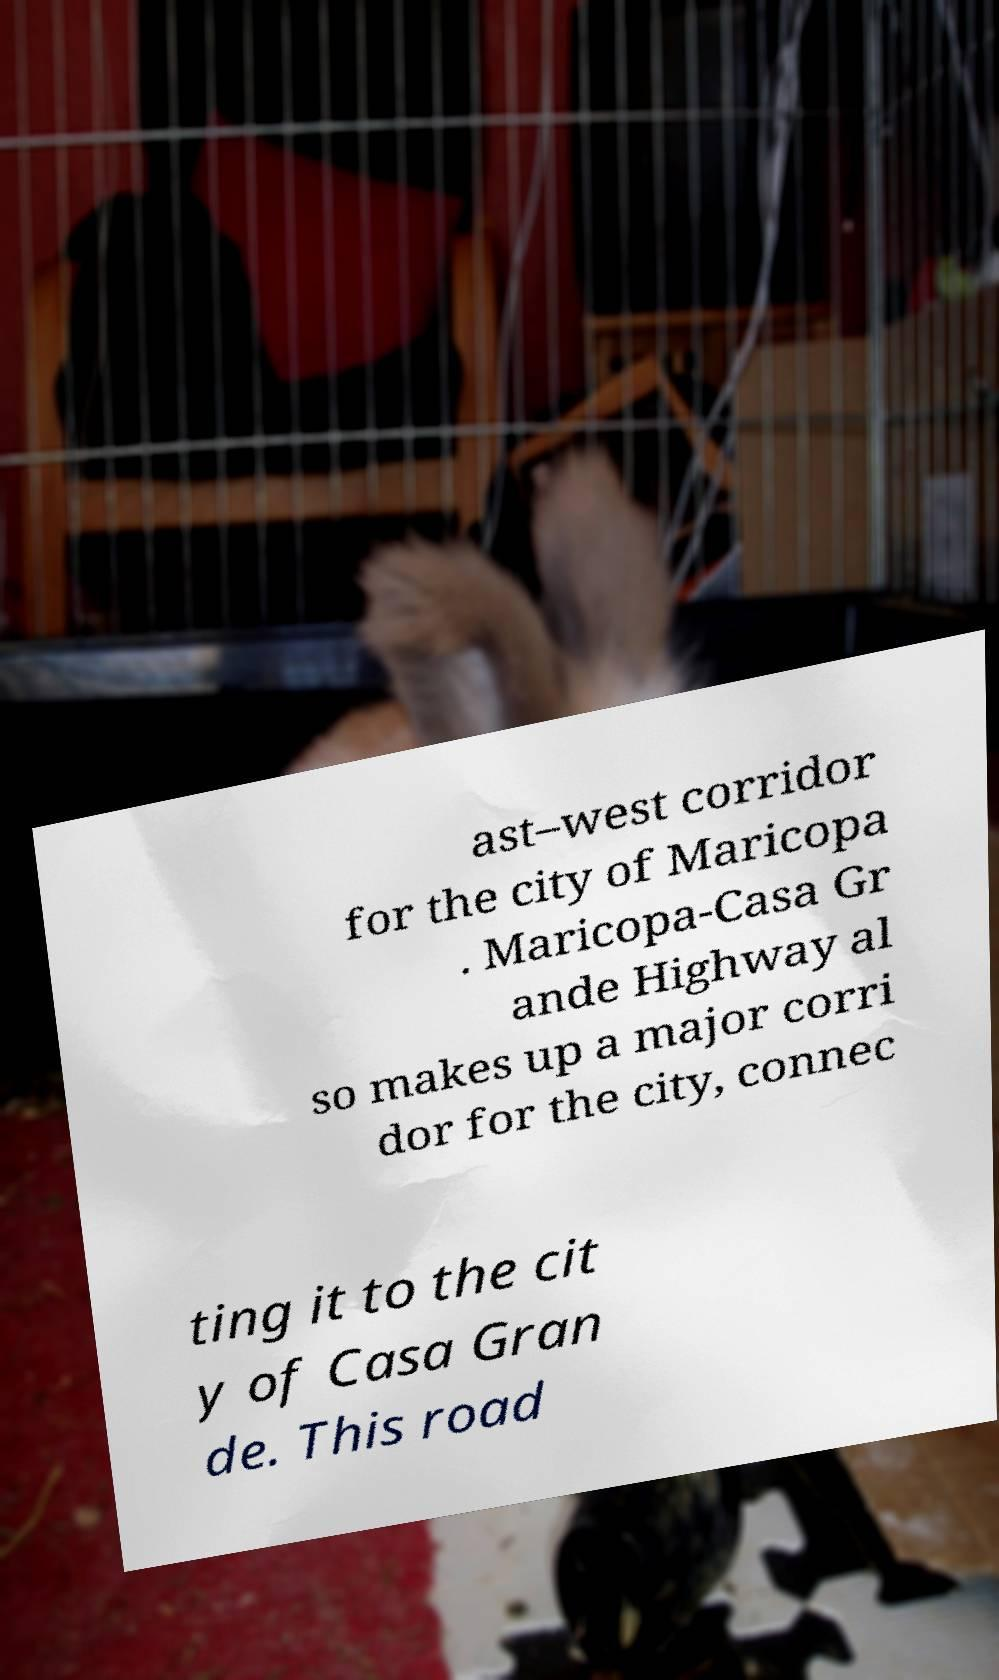I need the written content from this picture converted into text. Can you do that? ast–west corridor for the city of Maricopa . Maricopa-Casa Gr ande Highway al so makes up a major corri dor for the city, connec ting it to the cit y of Casa Gran de. This road 